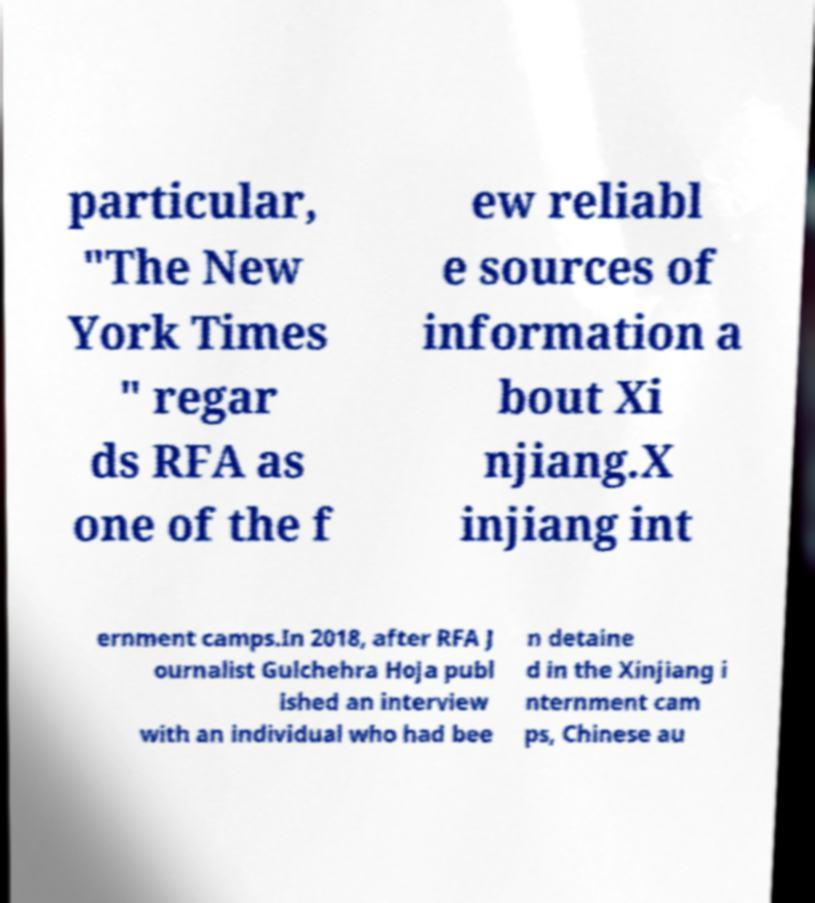I need the written content from this picture converted into text. Can you do that? particular, "The New York Times " regar ds RFA as one of the f ew reliabl e sources of information a bout Xi njiang.X injiang int ernment camps.In 2018, after RFA J ournalist Gulchehra Hoja publ ished an interview with an individual who had bee n detaine d in the Xinjiang i nternment cam ps, Chinese au 